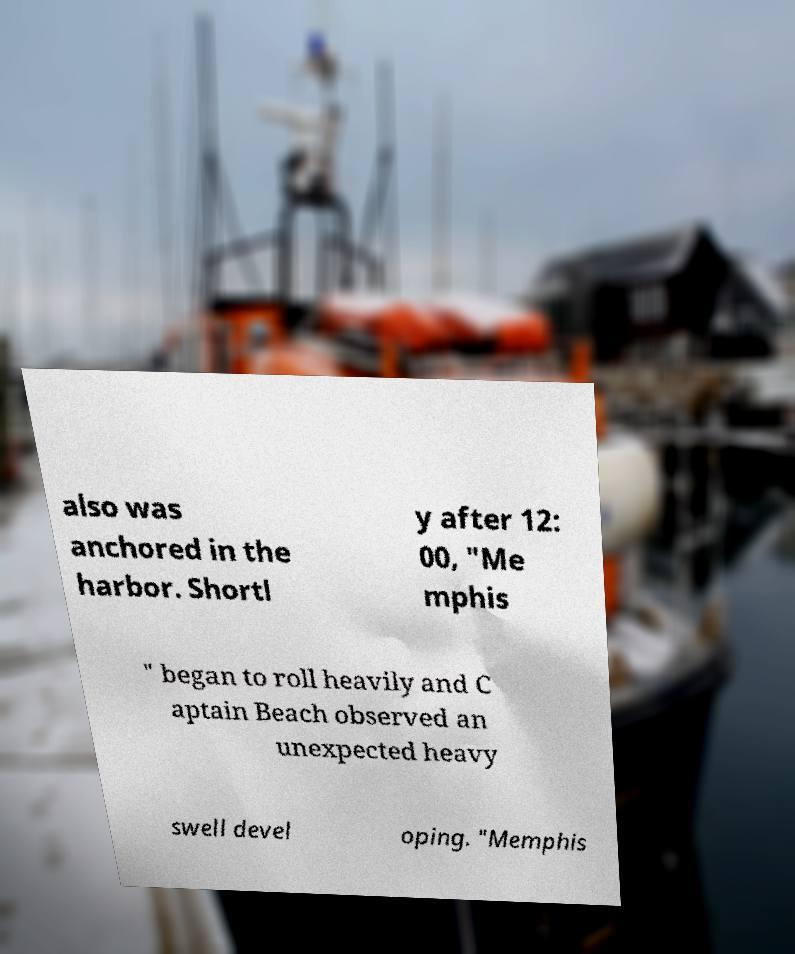I need the written content from this picture converted into text. Can you do that? also was anchored in the harbor. Shortl y after 12: 00, "Me mphis " began to roll heavily and C aptain Beach observed an unexpected heavy swell devel oping. "Memphis 